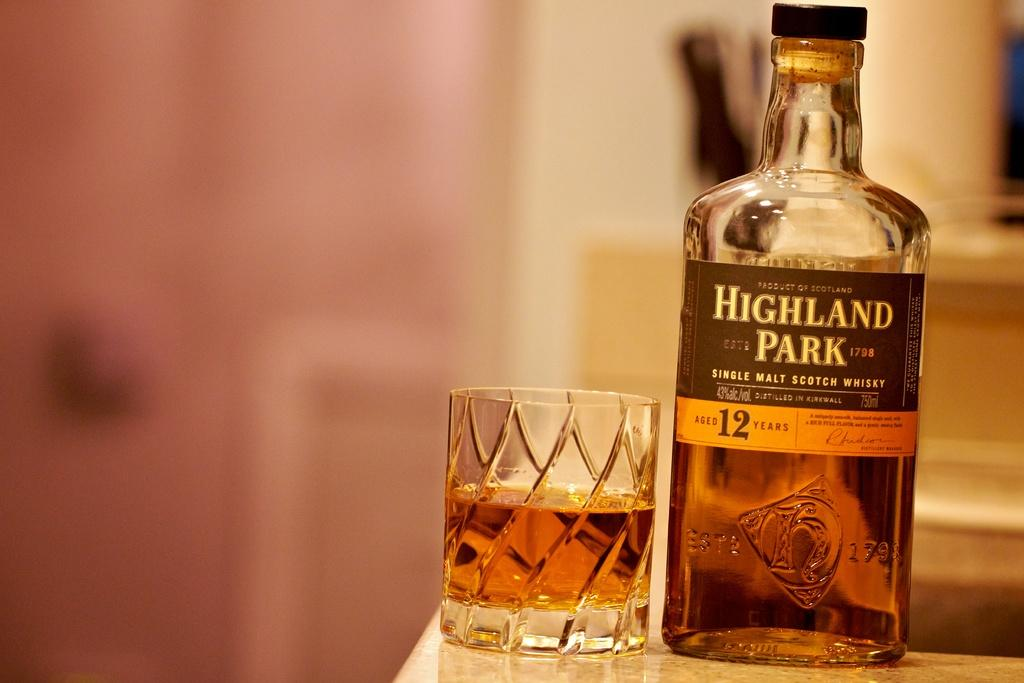<image>
Provide a brief description of the given image. A bottle of Highland Park Whiskey stands next to a half full glass. 